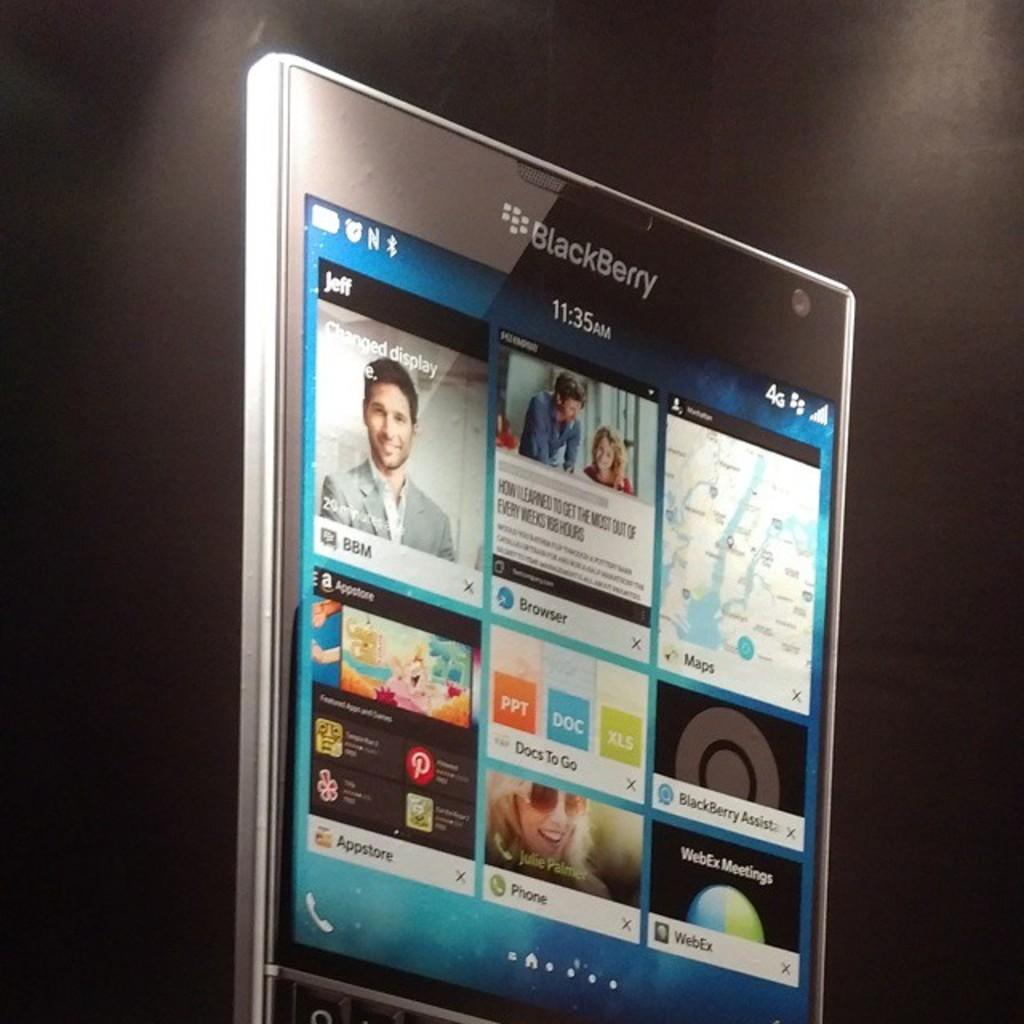Provide a one-sentence caption for the provided image. An advertisement for the new BlackBerry device against a black background. 